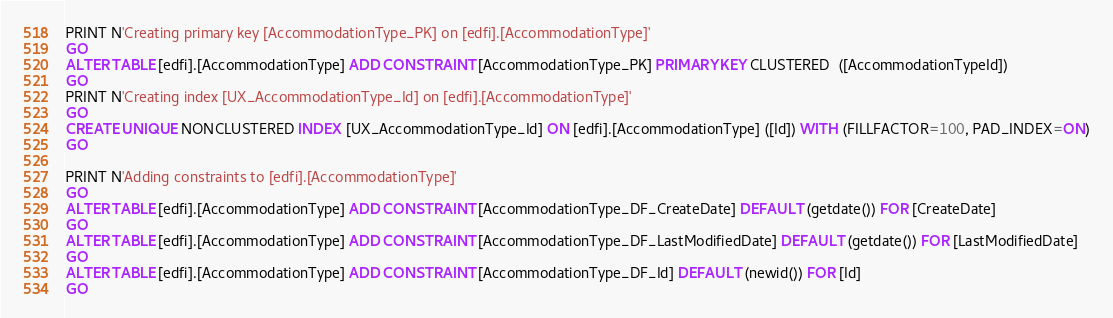<code> <loc_0><loc_0><loc_500><loc_500><_SQL_>
PRINT N'Creating primary key [AccommodationType_PK] on [edfi].[AccommodationType]'
GO
ALTER TABLE [edfi].[AccommodationType] ADD CONSTRAINT [AccommodationType_PK] PRIMARY KEY CLUSTERED  ([AccommodationTypeId])
GO
PRINT N'Creating index [UX_AccommodationType_Id] on [edfi].[AccommodationType]'
GO
CREATE UNIQUE NONCLUSTERED INDEX [UX_AccommodationType_Id] ON [edfi].[AccommodationType] ([Id]) WITH (FILLFACTOR=100, PAD_INDEX=ON)
GO

PRINT N'Adding constraints to [edfi].[AccommodationType]'
GO
ALTER TABLE [edfi].[AccommodationType] ADD CONSTRAINT [AccommodationType_DF_CreateDate] DEFAULT (getdate()) FOR [CreateDate]
GO
ALTER TABLE [edfi].[AccommodationType] ADD CONSTRAINT [AccommodationType_DF_LastModifiedDate] DEFAULT (getdate()) FOR [LastModifiedDate]
GO
ALTER TABLE [edfi].[AccommodationType] ADD CONSTRAINT [AccommodationType_DF_Id] DEFAULT (newid()) FOR [Id]
GO

</code> 